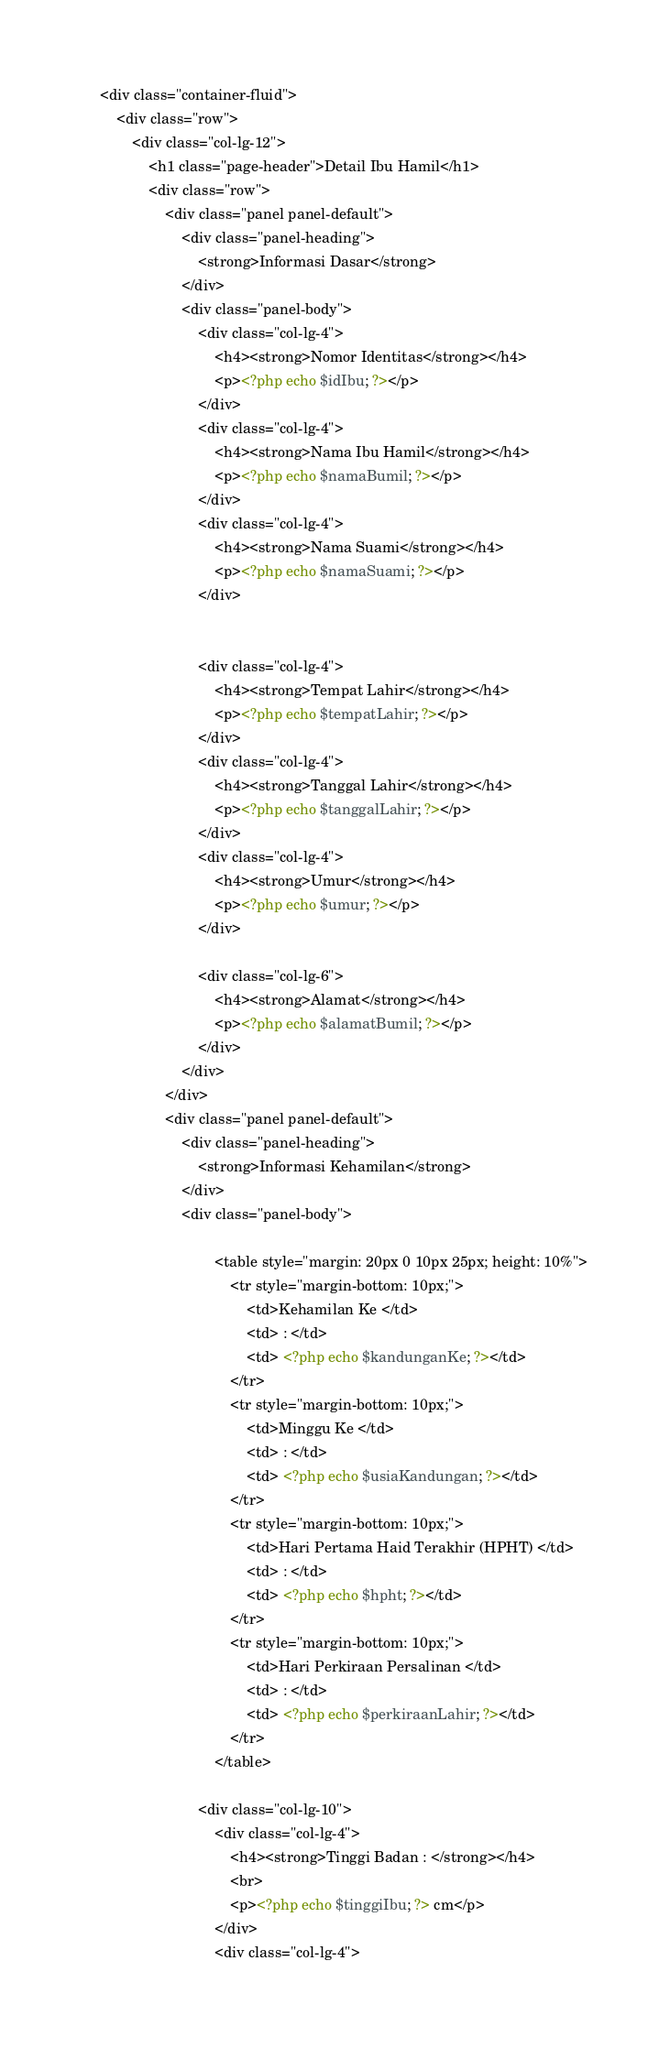Convert code to text. <code><loc_0><loc_0><loc_500><loc_500><_PHP_>    <div class="container-fluid">
        <div class="row">
            <div class="col-lg-12">
                <h1 class="page-header">Detail Ibu Hamil</h1>
                <div class="row">
                    <div class="panel panel-default">
                        <div class="panel-heading">
                            <strong>Informasi Dasar</strong>
                        </div>
                        <div class="panel-body"> 
                            <div class="col-lg-4">
                                <h4><strong>Nomor Identitas</strong></h4>
                                <p><?php echo $idIbu; ?></p>
                            </div>
                            <div class="col-lg-4">
                                <h4><strong>Nama Ibu Hamil</strong></h4>
                                <p><?php echo $namaBumil; ?></p>
                            </div>
                            <div class="col-lg-4">
                                <h4><strong>Nama Suami</strong></h4>
                                <p><?php echo $namaSuami; ?></p>
                            </div>
                        
                        
                            <div class="col-lg-4">
                                <h4><strong>Tempat Lahir</strong></h4>
                                <p><?php echo $tempatLahir; ?></p>
                            </div>
                            <div class="col-lg-4">
                                <h4><strong>Tanggal Lahir</strong></h4>
                                <p><?php echo $tanggalLahir; ?></p>
                            </div>
                            <div class="col-lg-4">
                                <h4><strong>Umur</strong></h4>
                                <p><?php echo $umur; ?></p>
                            </div>
                        
                            <div class="col-lg-6">
                                <h4><strong>Alamat</strong></h4>
                                <p><?php echo $alamatBumil; ?></p>
                            </div>
                        </div>
                    </div>
                    <div class="panel panel-default">
                        <div class="panel-heading">
                            <strong>Informasi Kehamilan</strong>
                        </div>
                        <div class="panel-body">
                            
                                <table style="margin: 20px 0 10px 25px; height: 10%">
                                    <tr style="margin-bottom: 10px;">
                                        <td>Kehamilan Ke </td>
                                        <td> : </td>
                                        <td> <?php echo $kandunganKe; ?></td>
                                    </tr>
                                    <tr style="margin-bottom: 10px;">
                                        <td>Minggu Ke </td>
                                        <td> : </td>
                                        <td> <?php echo $usiaKandungan; ?></td>
                                    </tr>
                                    <tr style="margin-bottom: 10px;">
                                        <td>Hari Pertama Haid Terakhir (HPHT) </td>
                                        <td> : </td>
                                        <td> <?php echo $hpht; ?></td>
                                    </tr>
                                    <tr style="margin-bottom: 10px;">
                                        <td>Hari Perkiraan Persalinan </td>
                                        <td> : </td>
                                        <td> <?php echo $perkiraanLahir; ?></td>
                                    </tr>
                                </table>
                            
                            <div class="col-lg-10">
                                <div class="col-lg-4">
                                    <h4><strong>Tinggi Badan : </strong></h4>
                                    <br>
                                    <p><?php echo $tinggiIbu; ?> cm</p>
                                </div>
                                <div class="col-lg-4"></code> 